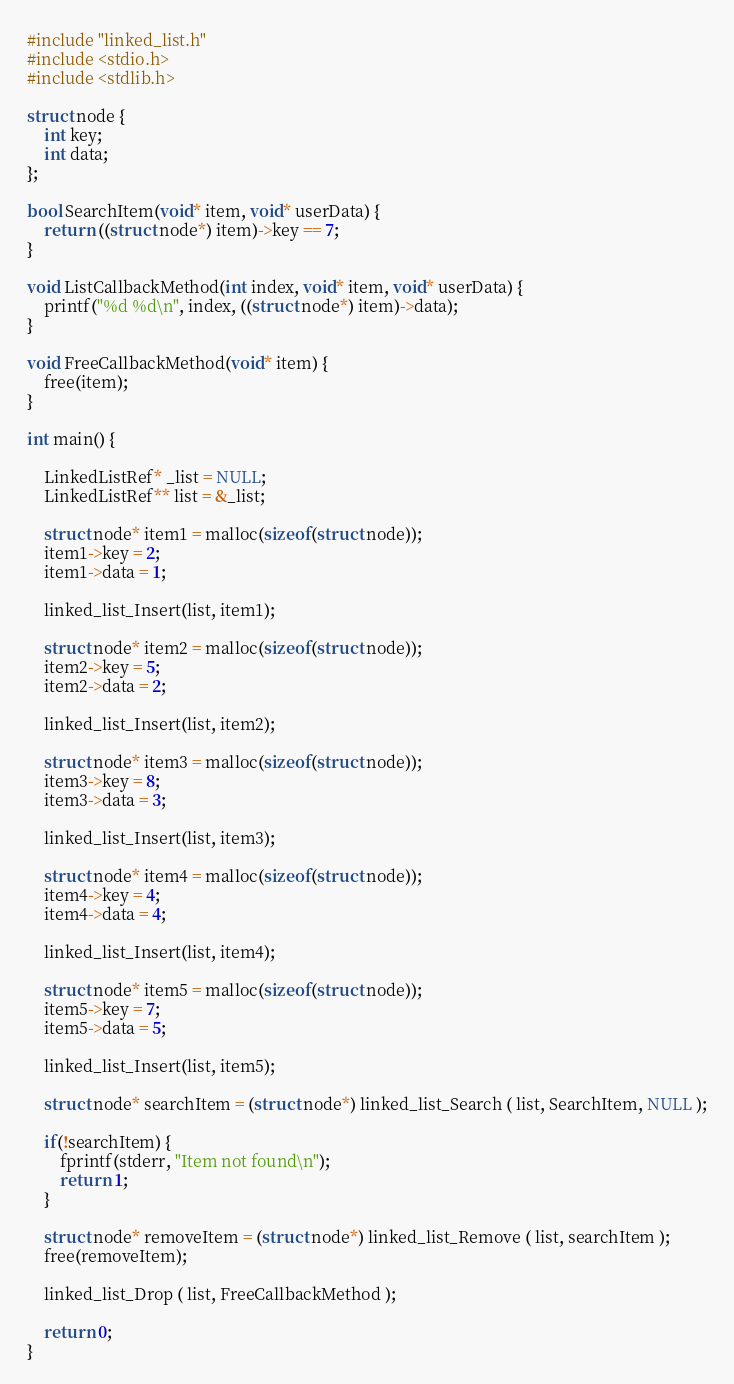Convert code to text. <code><loc_0><loc_0><loc_500><loc_500><_C_>#include "linked_list.h"
#include <stdio.h>
#include <stdlib.h>

struct node {
    int key;
    int data;
};

bool SearchItem(void* item, void* userData) {
    return ((struct node*) item)->key == 7;
}

void ListCallbackMethod(int index, void* item, void* userData) {
    printf("%d %d\n", index, ((struct node*) item)->data);
}

void FreeCallbackMethod(void* item) {
    free(item);
}

int main() {

    LinkedListRef* _list = NULL;
    LinkedListRef** list = &_list;

    struct node* item1 = malloc(sizeof(struct node));
    item1->key = 2;
    item1->data = 1;

    linked_list_Insert(list, item1);

    struct node* item2 = malloc(sizeof(struct node));
    item2->key = 5;
    item2->data = 2;

    linked_list_Insert(list, item2);

    struct node* item3 = malloc(sizeof(struct node));
    item3->key = 8;
    item3->data = 3;

    linked_list_Insert(list, item3);

    struct node* item4 = malloc(sizeof(struct node));
    item4->key = 4;
    item4->data = 4;

    linked_list_Insert(list, item4);

    struct node* item5 = malloc(sizeof(struct node));
    item5->key = 7;
    item5->data = 5;

    linked_list_Insert(list, item5);
    
    struct node* searchItem = (struct node*) linked_list_Search ( list, SearchItem, NULL );

    if(!searchItem) {
        fprintf(stderr, "Item not found\n");
        return 1;
    }

    struct node* removeItem = (struct node*) linked_list_Remove ( list, searchItem );
    free(removeItem);

    linked_list_Drop ( list, FreeCallbackMethod );

    return 0;
}
</code> 